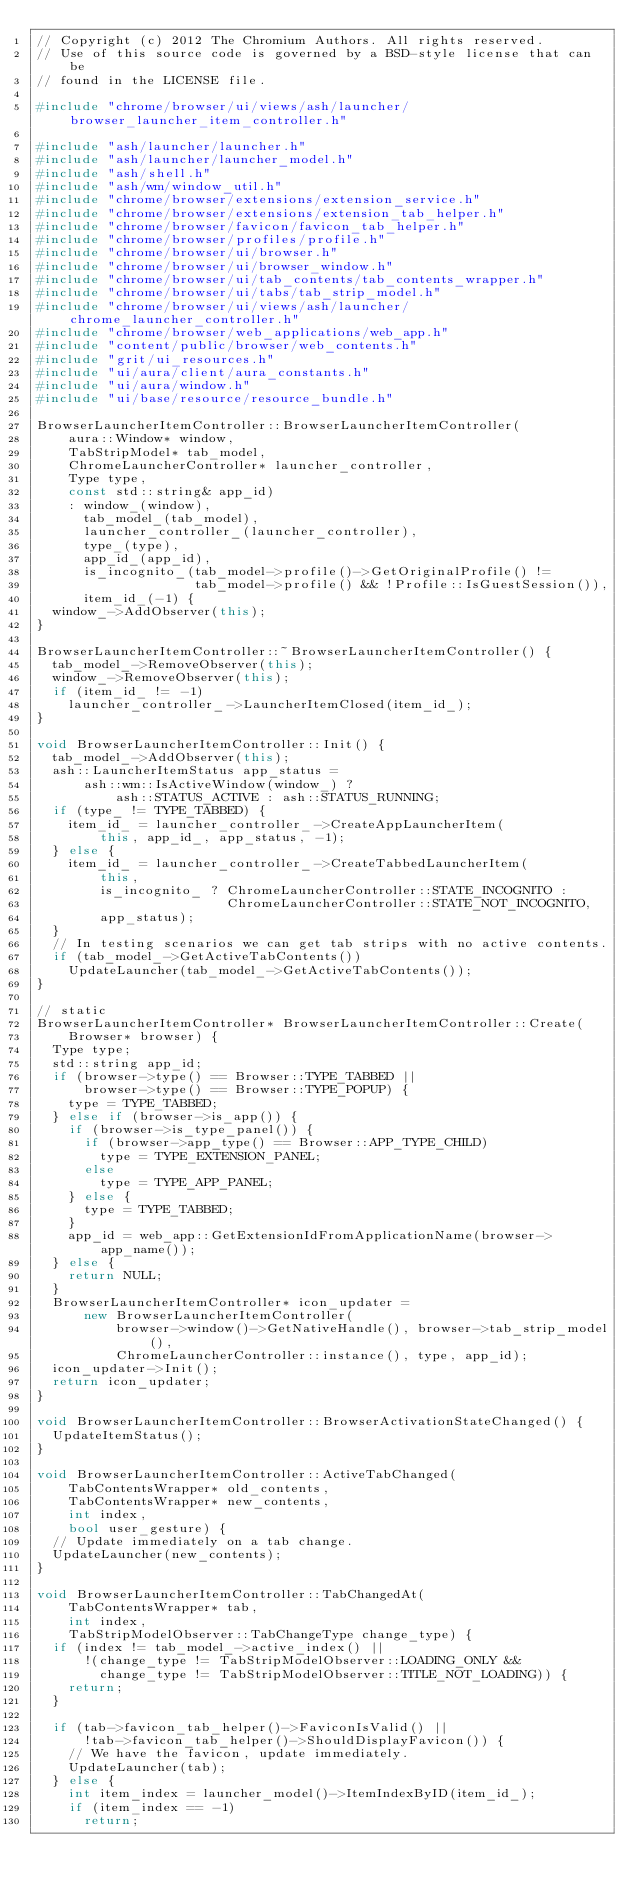Convert code to text. <code><loc_0><loc_0><loc_500><loc_500><_C++_>// Copyright (c) 2012 The Chromium Authors. All rights reserved.
// Use of this source code is governed by a BSD-style license that can be
// found in the LICENSE file.

#include "chrome/browser/ui/views/ash/launcher/browser_launcher_item_controller.h"

#include "ash/launcher/launcher.h"
#include "ash/launcher/launcher_model.h"
#include "ash/shell.h"
#include "ash/wm/window_util.h"
#include "chrome/browser/extensions/extension_service.h"
#include "chrome/browser/extensions/extension_tab_helper.h"
#include "chrome/browser/favicon/favicon_tab_helper.h"
#include "chrome/browser/profiles/profile.h"
#include "chrome/browser/ui/browser.h"
#include "chrome/browser/ui/browser_window.h"
#include "chrome/browser/ui/tab_contents/tab_contents_wrapper.h"
#include "chrome/browser/ui/tabs/tab_strip_model.h"
#include "chrome/browser/ui/views/ash/launcher/chrome_launcher_controller.h"
#include "chrome/browser/web_applications/web_app.h"
#include "content/public/browser/web_contents.h"
#include "grit/ui_resources.h"
#include "ui/aura/client/aura_constants.h"
#include "ui/aura/window.h"
#include "ui/base/resource/resource_bundle.h"

BrowserLauncherItemController::BrowserLauncherItemController(
    aura::Window* window,
    TabStripModel* tab_model,
    ChromeLauncherController* launcher_controller,
    Type type,
    const std::string& app_id)
    : window_(window),
      tab_model_(tab_model),
      launcher_controller_(launcher_controller),
      type_(type),
      app_id_(app_id),
      is_incognito_(tab_model->profile()->GetOriginalProfile() !=
                    tab_model->profile() && !Profile::IsGuestSession()),
      item_id_(-1) {
  window_->AddObserver(this);
}

BrowserLauncherItemController::~BrowserLauncherItemController() {
  tab_model_->RemoveObserver(this);
  window_->RemoveObserver(this);
  if (item_id_ != -1)
    launcher_controller_->LauncherItemClosed(item_id_);
}

void BrowserLauncherItemController::Init() {
  tab_model_->AddObserver(this);
  ash::LauncherItemStatus app_status =
      ash::wm::IsActiveWindow(window_) ?
          ash::STATUS_ACTIVE : ash::STATUS_RUNNING;
  if (type_ != TYPE_TABBED) {
    item_id_ = launcher_controller_->CreateAppLauncherItem(
        this, app_id_, app_status, -1);
  } else {
    item_id_ = launcher_controller_->CreateTabbedLauncherItem(
        this,
        is_incognito_ ? ChromeLauncherController::STATE_INCOGNITO :
                        ChromeLauncherController::STATE_NOT_INCOGNITO,
        app_status);
  }
  // In testing scenarios we can get tab strips with no active contents.
  if (tab_model_->GetActiveTabContents())
    UpdateLauncher(tab_model_->GetActiveTabContents());
}

// static
BrowserLauncherItemController* BrowserLauncherItemController::Create(
    Browser* browser) {
  Type type;
  std::string app_id;
  if (browser->type() == Browser::TYPE_TABBED ||
      browser->type() == Browser::TYPE_POPUP) {
    type = TYPE_TABBED;
  } else if (browser->is_app()) {
    if (browser->is_type_panel()) {
      if (browser->app_type() == Browser::APP_TYPE_CHILD)
        type = TYPE_EXTENSION_PANEL;
      else
        type = TYPE_APP_PANEL;
    } else {
      type = TYPE_TABBED;
    }
    app_id = web_app::GetExtensionIdFromApplicationName(browser->app_name());
  } else {
    return NULL;
  }
  BrowserLauncherItemController* icon_updater =
      new BrowserLauncherItemController(
          browser->window()->GetNativeHandle(), browser->tab_strip_model(),
          ChromeLauncherController::instance(), type, app_id);
  icon_updater->Init();
  return icon_updater;
}

void BrowserLauncherItemController::BrowserActivationStateChanged() {
  UpdateItemStatus();
}

void BrowserLauncherItemController::ActiveTabChanged(
    TabContentsWrapper* old_contents,
    TabContentsWrapper* new_contents,
    int index,
    bool user_gesture) {
  // Update immediately on a tab change.
  UpdateLauncher(new_contents);
}

void BrowserLauncherItemController::TabChangedAt(
    TabContentsWrapper* tab,
    int index,
    TabStripModelObserver::TabChangeType change_type) {
  if (index != tab_model_->active_index() ||
      !(change_type != TabStripModelObserver::LOADING_ONLY &&
        change_type != TabStripModelObserver::TITLE_NOT_LOADING)) {
    return;
  }

  if (tab->favicon_tab_helper()->FaviconIsValid() ||
      !tab->favicon_tab_helper()->ShouldDisplayFavicon()) {
    // We have the favicon, update immediately.
    UpdateLauncher(tab);
  } else {
    int item_index = launcher_model()->ItemIndexByID(item_id_);
    if (item_index == -1)
      return;</code> 